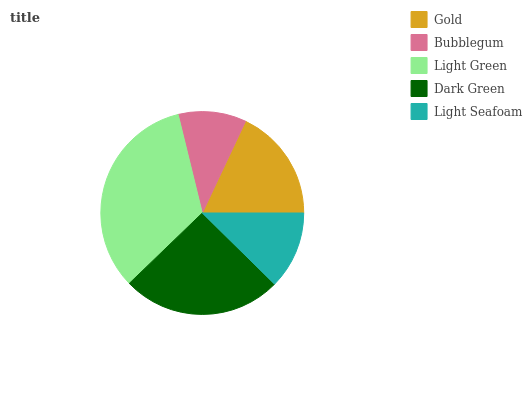Is Bubblegum the minimum?
Answer yes or no. Yes. Is Light Green the maximum?
Answer yes or no. Yes. Is Light Green the minimum?
Answer yes or no. No. Is Bubblegum the maximum?
Answer yes or no. No. Is Light Green greater than Bubblegum?
Answer yes or no. Yes. Is Bubblegum less than Light Green?
Answer yes or no. Yes. Is Bubblegum greater than Light Green?
Answer yes or no. No. Is Light Green less than Bubblegum?
Answer yes or no. No. Is Gold the high median?
Answer yes or no. Yes. Is Gold the low median?
Answer yes or no. Yes. Is Light Green the high median?
Answer yes or no. No. Is Bubblegum the low median?
Answer yes or no. No. 